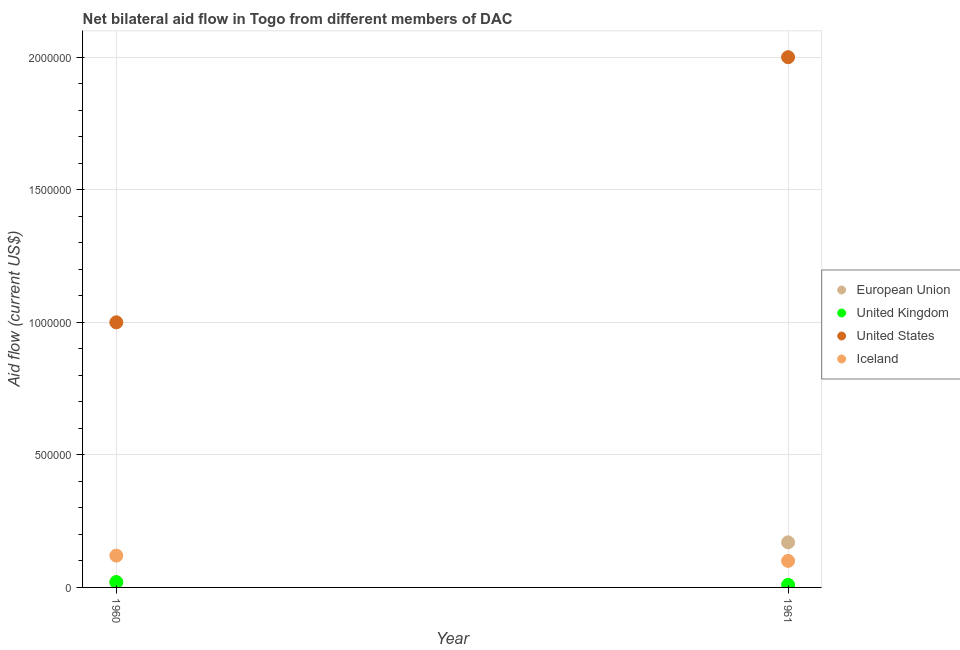How many different coloured dotlines are there?
Your response must be concise. 4. What is the amount of aid given by uk in 1961?
Offer a very short reply. 10000. Across all years, what is the maximum amount of aid given by uk?
Provide a short and direct response. 2.00e+04. Across all years, what is the minimum amount of aid given by eu?
Provide a short and direct response. 2.00e+04. What is the total amount of aid given by us in the graph?
Your response must be concise. 3.00e+06. What is the difference between the amount of aid given by eu in 1960 and that in 1961?
Your response must be concise. -1.50e+05. What is the difference between the amount of aid given by us in 1960 and the amount of aid given by uk in 1961?
Make the answer very short. 9.90e+05. What is the average amount of aid given by iceland per year?
Offer a very short reply. 1.10e+05. In the year 1961, what is the difference between the amount of aid given by iceland and amount of aid given by uk?
Keep it short and to the point. 9.00e+04. In how many years, is the amount of aid given by iceland greater than 1800000 US$?
Keep it short and to the point. 0. Is the amount of aid given by iceland in 1960 less than that in 1961?
Offer a very short reply. No. Is it the case that in every year, the sum of the amount of aid given by eu and amount of aid given by iceland is greater than the sum of amount of aid given by uk and amount of aid given by us?
Your response must be concise. No. Is the amount of aid given by uk strictly greater than the amount of aid given by eu over the years?
Your answer should be very brief. No. How many years are there in the graph?
Your response must be concise. 2. What is the difference between two consecutive major ticks on the Y-axis?
Offer a terse response. 5.00e+05. Are the values on the major ticks of Y-axis written in scientific E-notation?
Offer a very short reply. No. Does the graph contain any zero values?
Provide a short and direct response. No. What is the title of the graph?
Offer a very short reply. Net bilateral aid flow in Togo from different members of DAC. What is the Aid flow (current US$) of European Union in 1960?
Offer a very short reply. 2.00e+04. What is the Aid flow (current US$) of European Union in 1961?
Ensure brevity in your answer.  1.70e+05. Across all years, what is the maximum Aid flow (current US$) of United Kingdom?
Your answer should be compact. 2.00e+04. Across all years, what is the maximum Aid flow (current US$) of Iceland?
Offer a very short reply. 1.20e+05. Across all years, what is the minimum Aid flow (current US$) of European Union?
Your response must be concise. 2.00e+04. Across all years, what is the minimum Aid flow (current US$) in United Kingdom?
Provide a succinct answer. 10000. Across all years, what is the minimum Aid flow (current US$) of United States?
Make the answer very short. 1.00e+06. What is the total Aid flow (current US$) of European Union in the graph?
Offer a terse response. 1.90e+05. What is the total Aid flow (current US$) of United Kingdom in the graph?
Make the answer very short. 3.00e+04. What is the total Aid flow (current US$) in Iceland in the graph?
Ensure brevity in your answer.  2.20e+05. What is the difference between the Aid flow (current US$) in European Union in 1960 and that in 1961?
Keep it short and to the point. -1.50e+05. What is the difference between the Aid flow (current US$) in United States in 1960 and that in 1961?
Ensure brevity in your answer.  -1.00e+06. What is the difference between the Aid flow (current US$) of European Union in 1960 and the Aid flow (current US$) of United States in 1961?
Offer a very short reply. -1.98e+06. What is the difference between the Aid flow (current US$) in United Kingdom in 1960 and the Aid flow (current US$) in United States in 1961?
Provide a short and direct response. -1.98e+06. What is the difference between the Aid flow (current US$) in United Kingdom in 1960 and the Aid flow (current US$) in Iceland in 1961?
Provide a succinct answer. -8.00e+04. What is the difference between the Aid flow (current US$) in United States in 1960 and the Aid flow (current US$) in Iceland in 1961?
Your answer should be compact. 9.00e+05. What is the average Aid flow (current US$) of European Union per year?
Keep it short and to the point. 9.50e+04. What is the average Aid flow (current US$) in United Kingdom per year?
Provide a short and direct response. 1.50e+04. What is the average Aid flow (current US$) of United States per year?
Your answer should be compact. 1.50e+06. What is the average Aid flow (current US$) in Iceland per year?
Keep it short and to the point. 1.10e+05. In the year 1960, what is the difference between the Aid flow (current US$) of European Union and Aid flow (current US$) of United Kingdom?
Ensure brevity in your answer.  0. In the year 1960, what is the difference between the Aid flow (current US$) of European Union and Aid flow (current US$) of United States?
Offer a very short reply. -9.80e+05. In the year 1960, what is the difference between the Aid flow (current US$) of United Kingdom and Aid flow (current US$) of United States?
Provide a succinct answer. -9.80e+05. In the year 1960, what is the difference between the Aid flow (current US$) in United Kingdom and Aid flow (current US$) in Iceland?
Your answer should be compact. -1.00e+05. In the year 1960, what is the difference between the Aid flow (current US$) of United States and Aid flow (current US$) of Iceland?
Your answer should be compact. 8.80e+05. In the year 1961, what is the difference between the Aid flow (current US$) of European Union and Aid flow (current US$) of United States?
Offer a very short reply. -1.83e+06. In the year 1961, what is the difference between the Aid flow (current US$) in European Union and Aid flow (current US$) in Iceland?
Ensure brevity in your answer.  7.00e+04. In the year 1961, what is the difference between the Aid flow (current US$) of United Kingdom and Aid flow (current US$) of United States?
Provide a short and direct response. -1.99e+06. In the year 1961, what is the difference between the Aid flow (current US$) of United States and Aid flow (current US$) of Iceland?
Your answer should be very brief. 1.90e+06. What is the ratio of the Aid flow (current US$) of European Union in 1960 to that in 1961?
Your response must be concise. 0.12. What is the ratio of the Aid flow (current US$) in United States in 1960 to that in 1961?
Provide a short and direct response. 0.5. What is the difference between the highest and the second highest Aid flow (current US$) of European Union?
Give a very brief answer. 1.50e+05. What is the difference between the highest and the second highest Aid flow (current US$) in United Kingdom?
Ensure brevity in your answer.  10000. What is the difference between the highest and the second highest Aid flow (current US$) in United States?
Provide a short and direct response. 1.00e+06. What is the difference between the highest and the lowest Aid flow (current US$) in European Union?
Make the answer very short. 1.50e+05. What is the difference between the highest and the lowest Aid flow (current US$) of Iceland?
Your answer should be compact. 2.00e+04. 